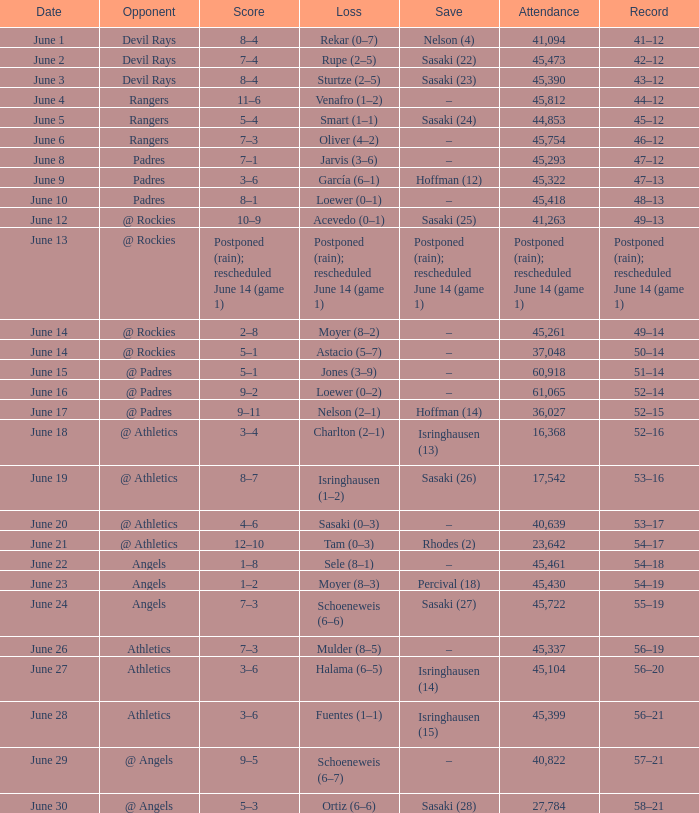What was the outcome of the mariners game when they held a record of 56–21? 3–6. 